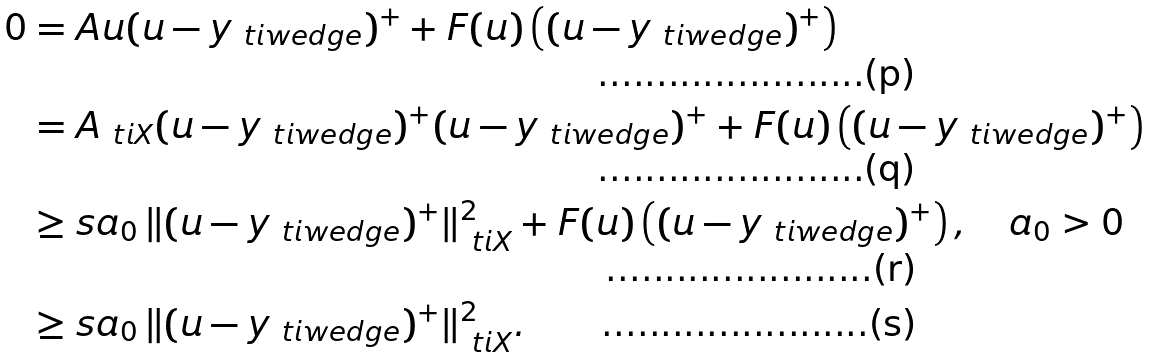Convert formula to latex. <formula><loc_0><loc_0><loc_500><loc_500>0 & = A u ( u - y _ { \ t i w e d g e } ) ^ { + } + F ( u ) \left ( ( u - y _ { \ t i w e d g e } ) ^ { + } \right ) \\ & = A _ { \ t i X } ( u - y _ { \ t i w e d g e } ) ^ { + } ( u - y _ { \ t i w e d g e } ) ^ { + } + F ( u ) \left ( ( u - y _ { \ t i w e d g e } ) ^ { + } \right ) \\ & \geq s a _ { 0 } \, \| ( u - y _ { \ t i w e d g e } ) ^ { + } \| _ { \ t i X } ^ { 2 } + F ( u ) \left ( ( u - y _ { \ t i w e d g e } ) ^ { + } \right ) , \quad a _ { 0 } > 0 \\ & \geq s a _ { 0 } \, \| ( u - y _ { \ t i w e d g e } ) ^ { + } \| _ { \ t i X } ^ { 2 } .</formula> 